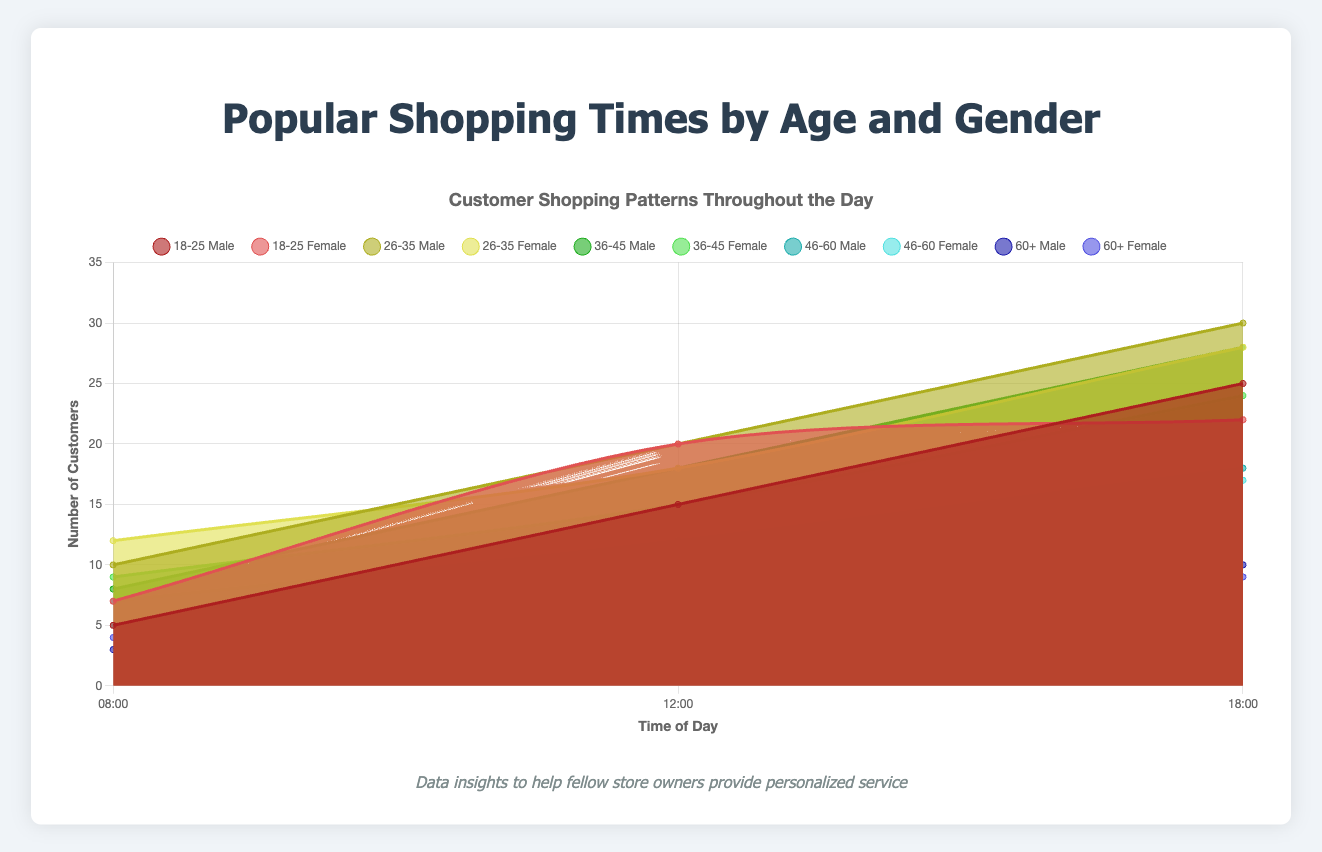What are the titles of the chart and the axes? The chart title is "Popular Shopping Times by Age and Gender". The x-axis is titled "Time of Day", and the y-axis is titled "Number of Customers".
Answer: "Popular Shopping Times by Age and Gender", "Time of Day", "Number of Customers" Which age group has the highest number of male customers at 18:00? Look for the data points for male customers at 18:00 across all age groups. The highest value is for the 26-35 age group with 30 customers.
Answer: 26-35 How many customers are there in total for the age group 18-25 at 12:00? Add the number of male and female customers for the age group 18-25 at 12:00. There are 15 (Male) + 20 (Female) = 35 customers.
Answer: 35 Between 08:00 and 12:00, which gender sees a higher increase in customers in the 36-45 age group? For males: 18 at 12:00 minus 8 at 08:00 equals an increase of 10. For females: 15 at 12:00 minus 9 at 08:00 equals an increase of 6. So males have a higher increase.
Answer: Male Which time of the day has the lowest number of customers for the age group 60+? Look at the number of customers for all three times (08:00, 12:00, and 18:00) for the 60+ age group. The lowest number is at 08:00, with 3 (Male) + 4 (Female) = 7 customers.
Answer: 08:00 What is the total number of female customers at 18:00 across all age groups? Sum the number of female customers at 18:00 for all age groups: 22 (18-25) + 28 (26-35) + 24 (36-45) + 17 (46-60) + 9 (60+) = 100.
Answer: 100 How do the shopping patterns differ between males and females in the 26-35 age group at 12:00? Compare the number of customers: Males have 20, and females have 18. Males slightly outnumber females by 2 customers.
Answer: Males outnumber by 2 Which gender has more customers in total at 08:00 in the age group 46-60? Compare the number of male and female customers at 08:00 for the 46-60 age group. Males have 7, and females have 5. Males have more customers.
Answer: Male 